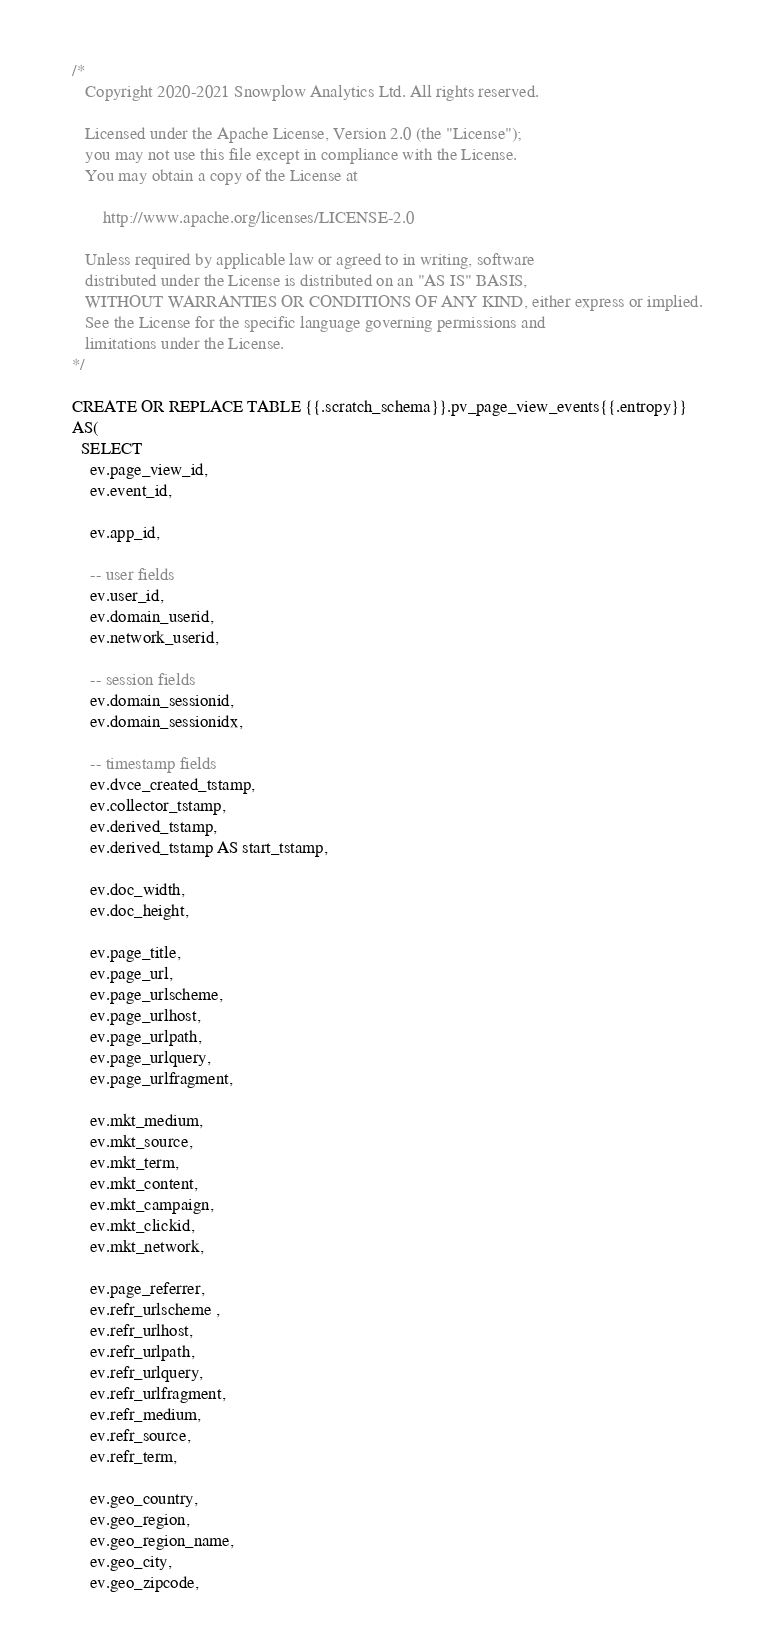Convert code to text. <code><loc_0><loc_0><loc_500><loc_500><_SQL_>/*
   Copyright 2020-2021 Snowplow Analytics Ltd. All rights reserved.

   Licensed under the Apache License, Version 2.0 (the "License");
   you may not use this file except in compliance with the License.
   You may obtain a copy of the License at

       http://www.apache.org/licenses/LICENSE-2.0

   Unless required by applicable law or agreed to in writing, software
   distributed under the License is distributed on an "AS IS" BASIS,
   WITHOUT WARRANTIES OR CONDITIONS OF ANY KIND, either express or implied.
   See the License for the specific language governing permissions and
   limitations under the License.
*/

CREATE OR REPLACE TABLE {{.scratch_schema}}.pv_page_view_events{{.entropy}}
AS(
  SELECT
    ev.page_view_id,
    ev.event_id,

    ev.app_id,

    -- user fields
    ev.user_id,
    ev.domain_userid,
    ev.network_userid,

    -- session fields
    ev.domain_sessionid,
    ev.domain_sessionidx,

    -- timestamp fields
    ev.dvce_created_tstamp,
    ev.collector_tstamp,
    ev.derived_tstamp,
    ev.derived_tstamp AS start_tstamp,

    ev.doc_width,
    ev.doc_height,

    ev.page_title,
    ev.page_url,
    ev.page_urlscheme,
    ev.page_urlhost,
    ev.page_urlpath,
    ev.page_urlquery,
    ev.page_urlfragment,

    ev.mkt_medium,
    ev.mkt_source,
    ev.mkt_term,
    ev.mkt_content,
    ev.mkt_campaign,
    ev.mkt_clickid,
    ev.mkt_network,

    ev.page_referrer,
    ev.refr_urlscheme ,
    ev.refr_urlhost,
    ev.refr_urlpath,
    ev.refr_urlquery,
    ev.refr_urlfragment,
    ev.refr_medium,
    ev.refr_source,
    ev.refr_term,

    ev.geo_country,
    ev.geo_region,
    ev.geo_region_name,
    ev.geo_city,
    ev.geo_zipcode,</code> 